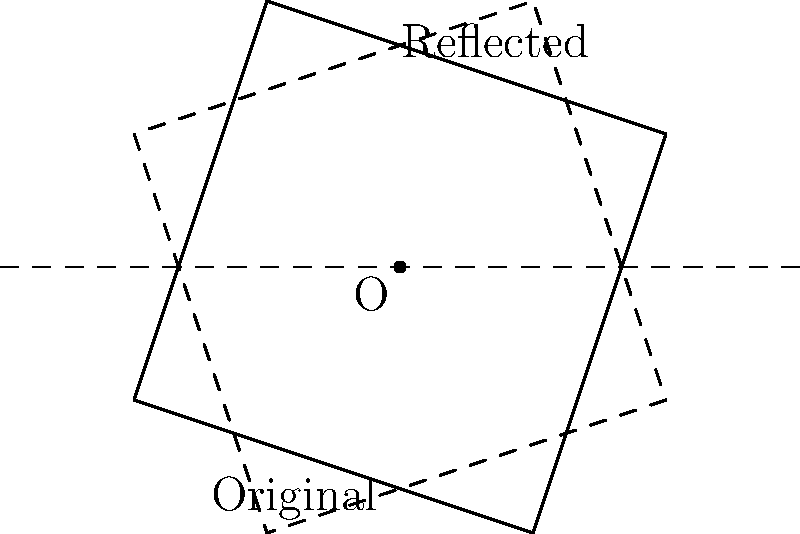In the diagram, a turntable is represented by the quadrilateral ABCD. If this turntable is reflected across the x-axis (the dashed horizontal line), what will be the coordinates of point B after reflection? Express your answer as an ordered pair $(x,y)$. To find the coordinates of point B after reflection across the x-axis, we can follow these steps:

1. Identify the original coordinates of point B: $(-1, 2)$

2. Recall that reflection across the x-axis:
   - Keeps the x-coordinate the same
   - Changes the sign of the y-coordinate

3. Apply the reflection:
   - x-coordinate remains $-1$
   - y-coordinate changes from $2$ to $-2$

4. The new coordinates of B after reflection will be $(-1, -2)$

This reflection mimics flipping a Heltah Skeltah vinyl record from top to bottom, maintaining its left-right position but inverting its vertical position.
Answer: $(-1, -2)$ 